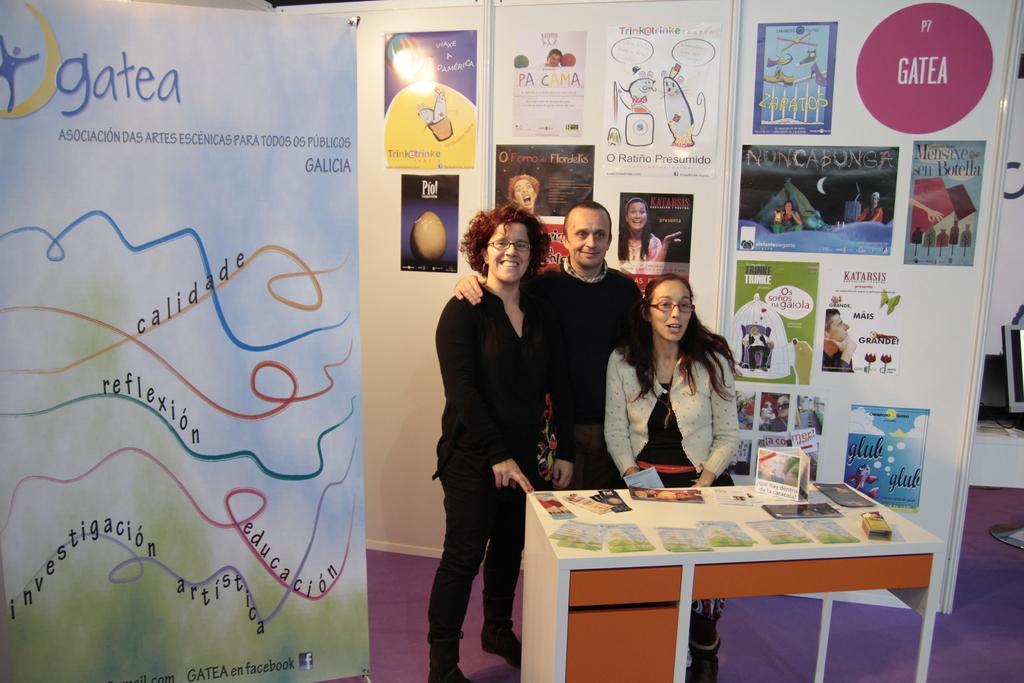In one or two sentences, can you explain what this image depicts? In this image on the right side, I can see a computer. I can see some objects on the table. I can see three people. In the background, I can see the posters on the wall. 